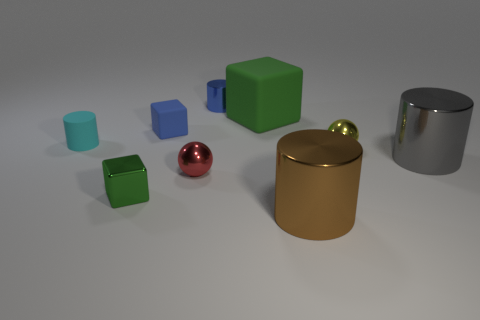Are there more large brown metallic cylinders behind the tiny cyan matte cylinder than shiny things left of the large gray cylinder?
Offer a very short reply. No. What number of gray shiny cylinders have the same size as the cyan cylinder?
Ensure brevity in your answer.  0. Is the number of brown cylinders behind the big green matte thing less than the number of red metallic objects that are to the left of the red sphere?
Offer a terse response. No. Are there any other red matte things of the same shape as the small red thing?
Keep it short and to the point. No. Is the tiny cyan thing the same shape as the green metal object?
Your answer should be compact. No. What number of tiny objects are red shiny things or green shiny blocks?
Ensure brevity in your answer.  2. Are there more small purple metallic spheres than big gray objects?
Ensure brevity in your answer.  No. There is another blue block that is the same material as the large block; what is its size?
Ensure brevity in your answer.  Small. Do the thing left of the metallic cube and the shiny ball that is to the right of the brown cylinder have the same size?
Provide a succinct answer. Yes. How many objects are cylinders to the right of the tiny rubber cylinder or yellow cylinders?
Ensure brevity in your answer.  3. 